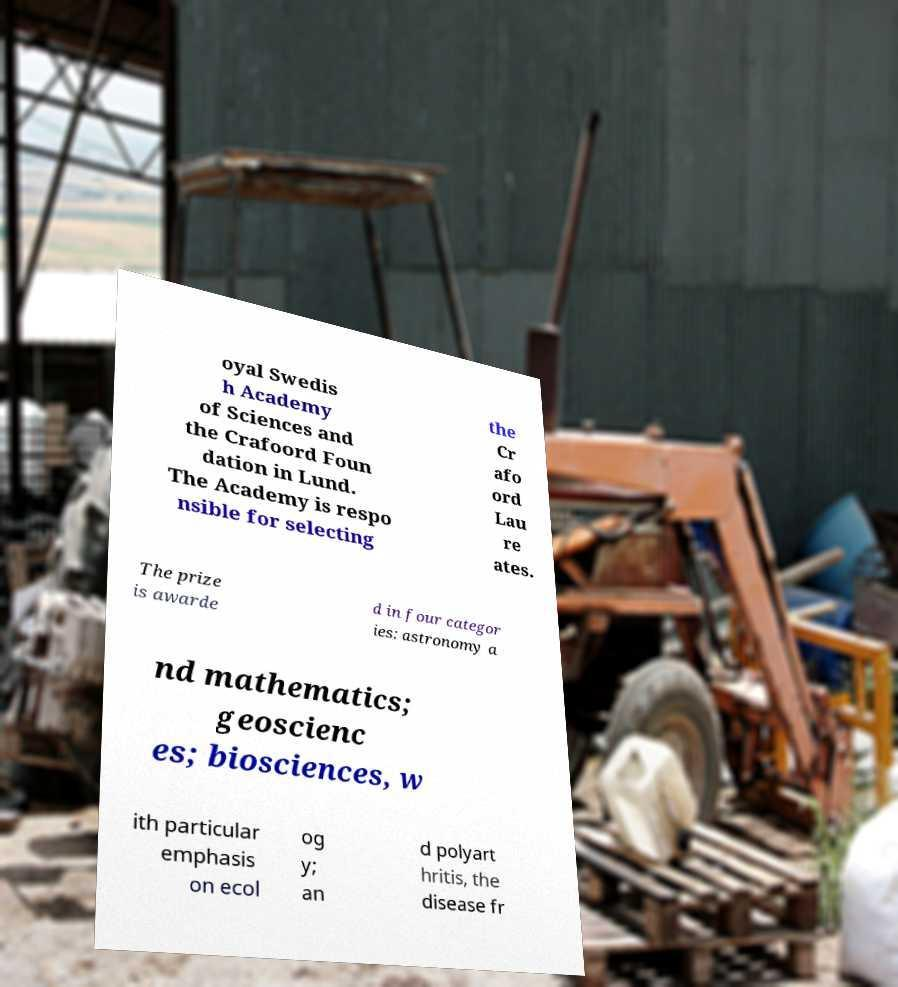I need the written content from this picture converted into text. Can you do that? oyal Swedis h Academy of Sciences and the Crafoord Foun dation in Lund. The Academy is respo nsible for selecting the Cr afo ord Lau re ates. The prize is awarde d in four categor ies: astronomy a nd mathematics; geoscienc es; biosciences, w ith particular emphasis on ecol og y; an d polyart hritis, the disease fr 